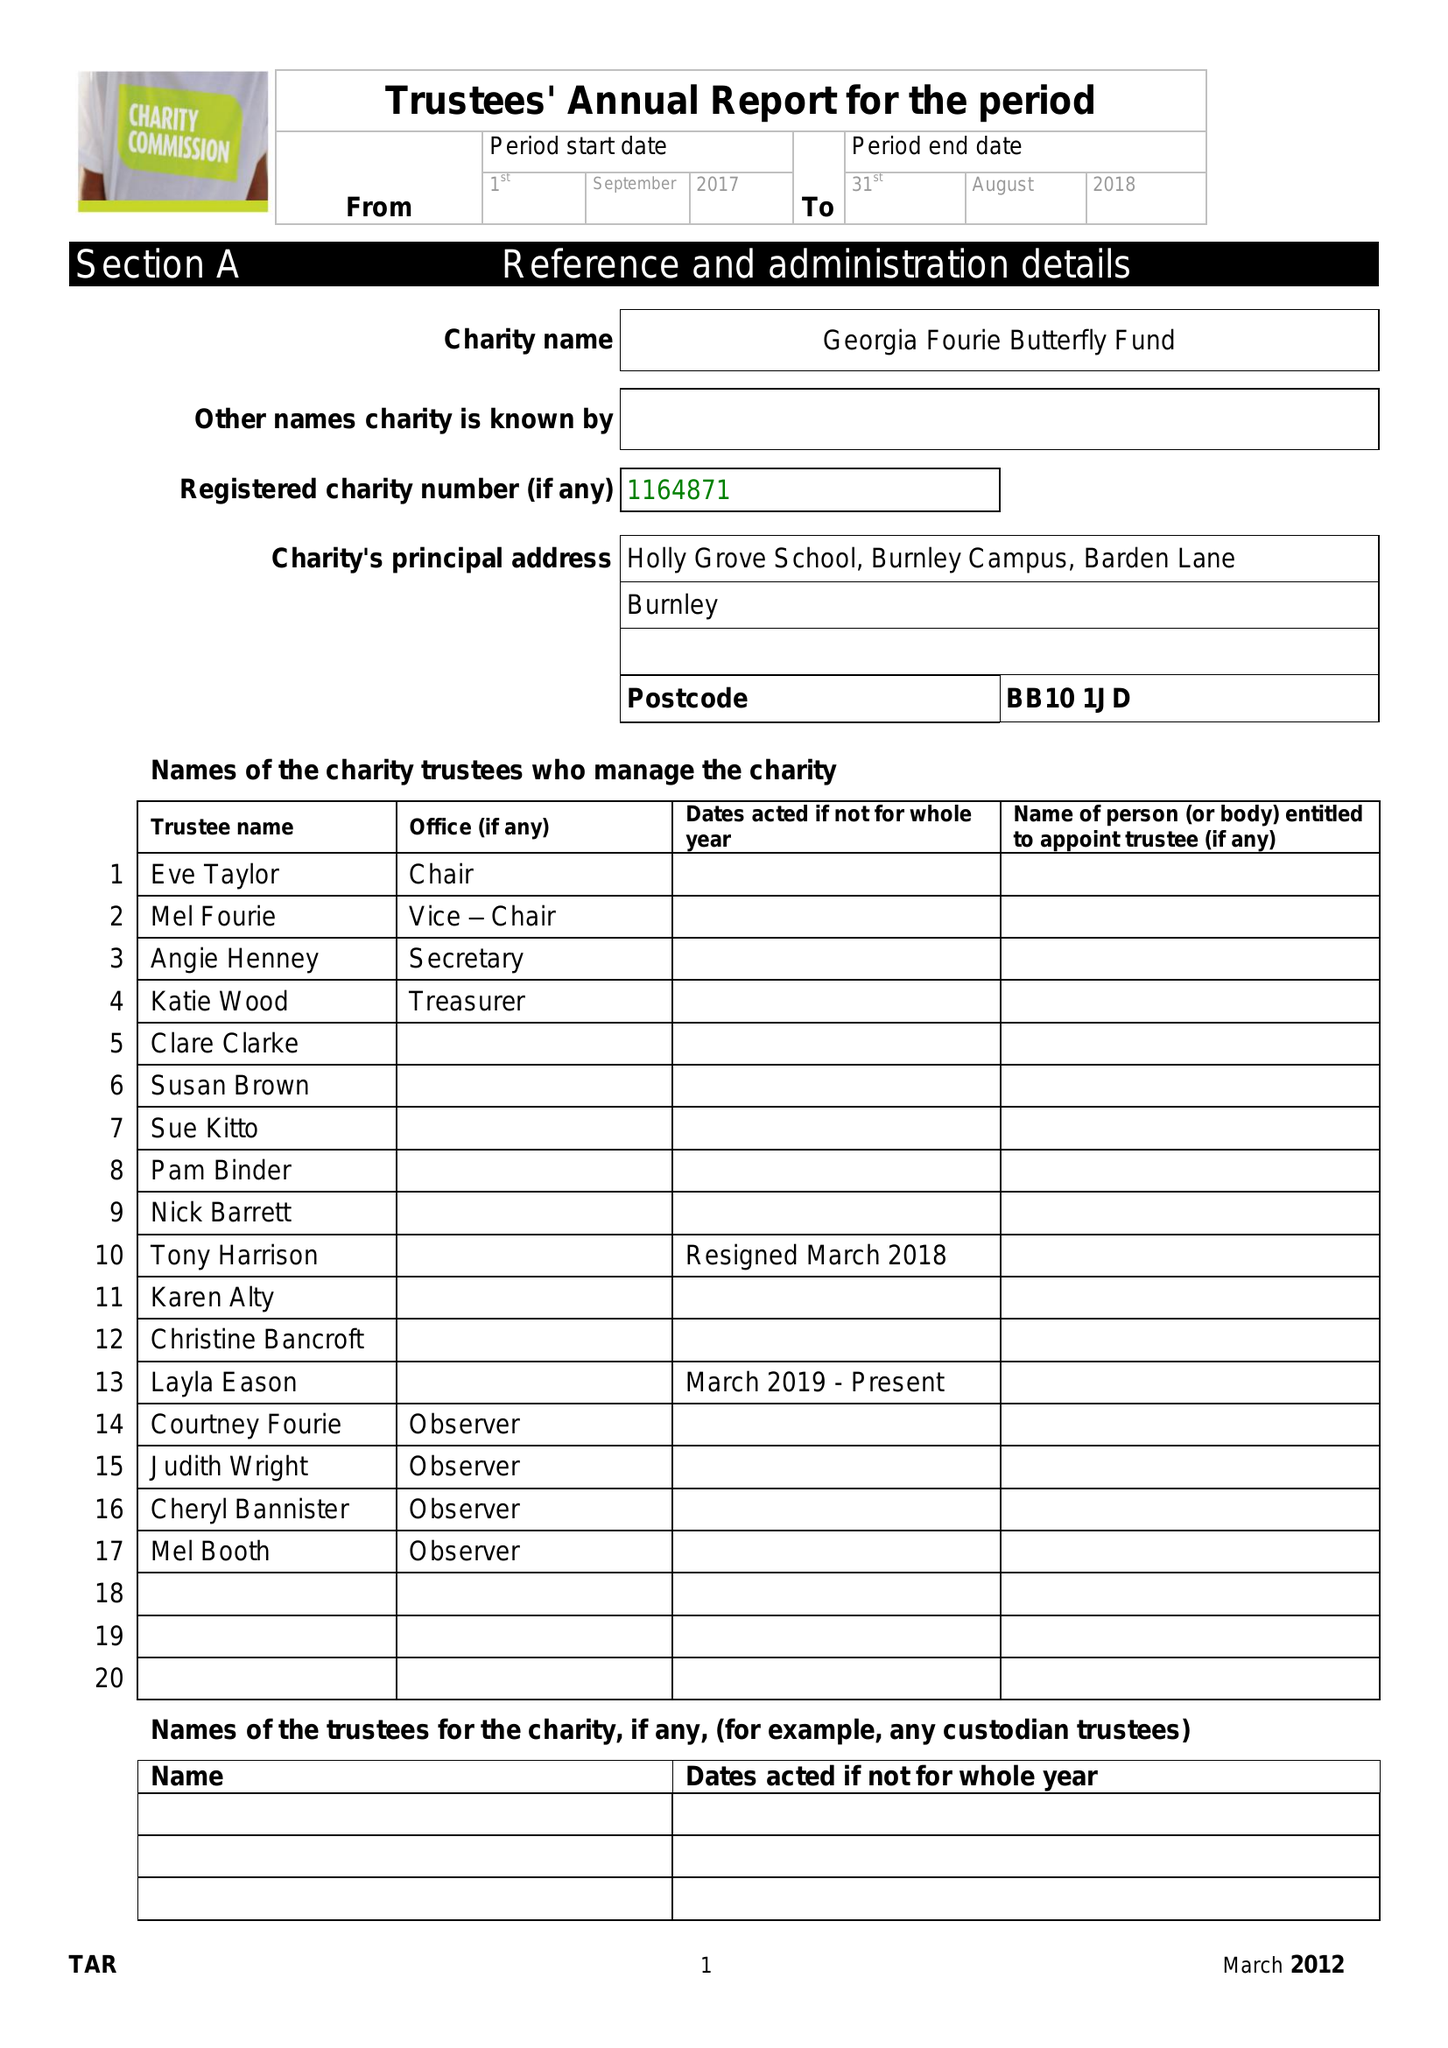What is the value for the address__postcode?
Answer the question using a single word or phrase. BB10 1JD 